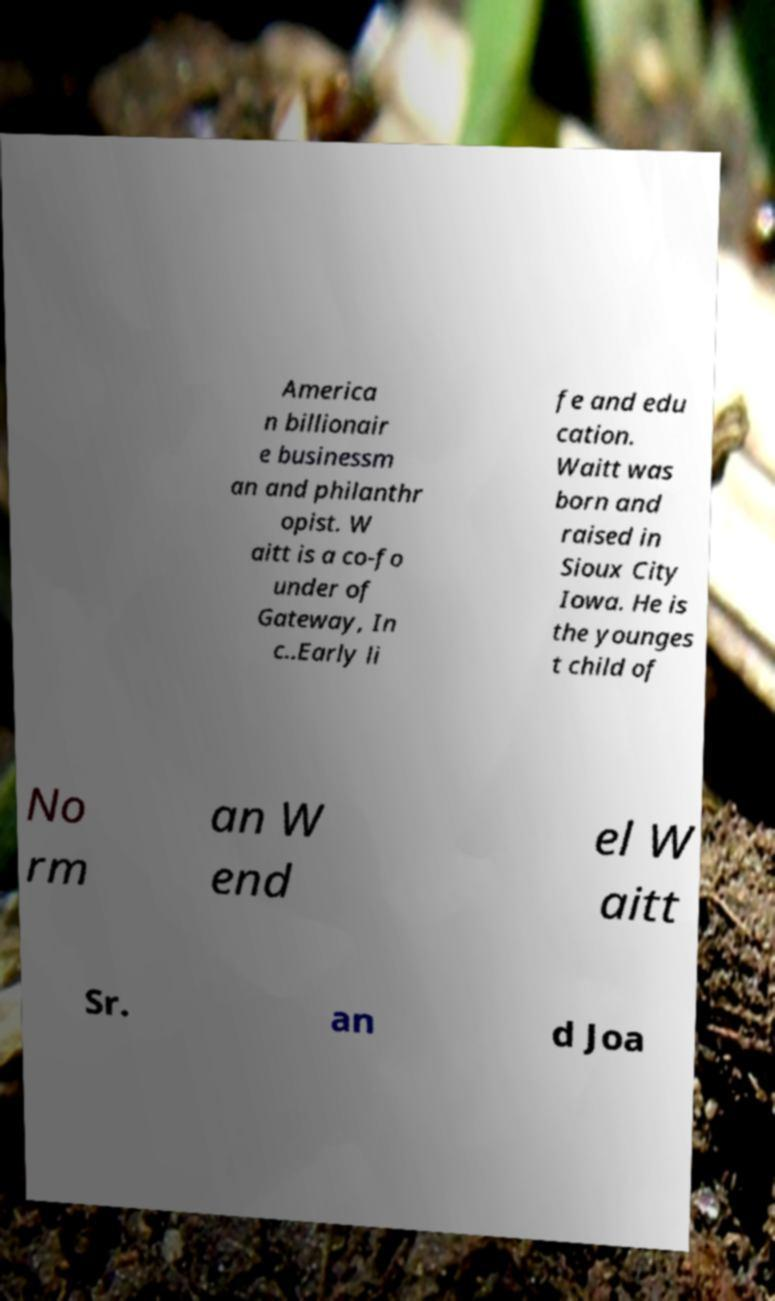What messages or text are displayed in this image? I need them in a readable, typed format. America n billionair e businessm an and philanthr opist. W aitt is a co-fo under of Gateway, In c..Early li fe and edu cation. Waitt was born and raised in Sioux City Iowa. He is the younges t child of No rm an W end el W aitt Sr. an d Joa 